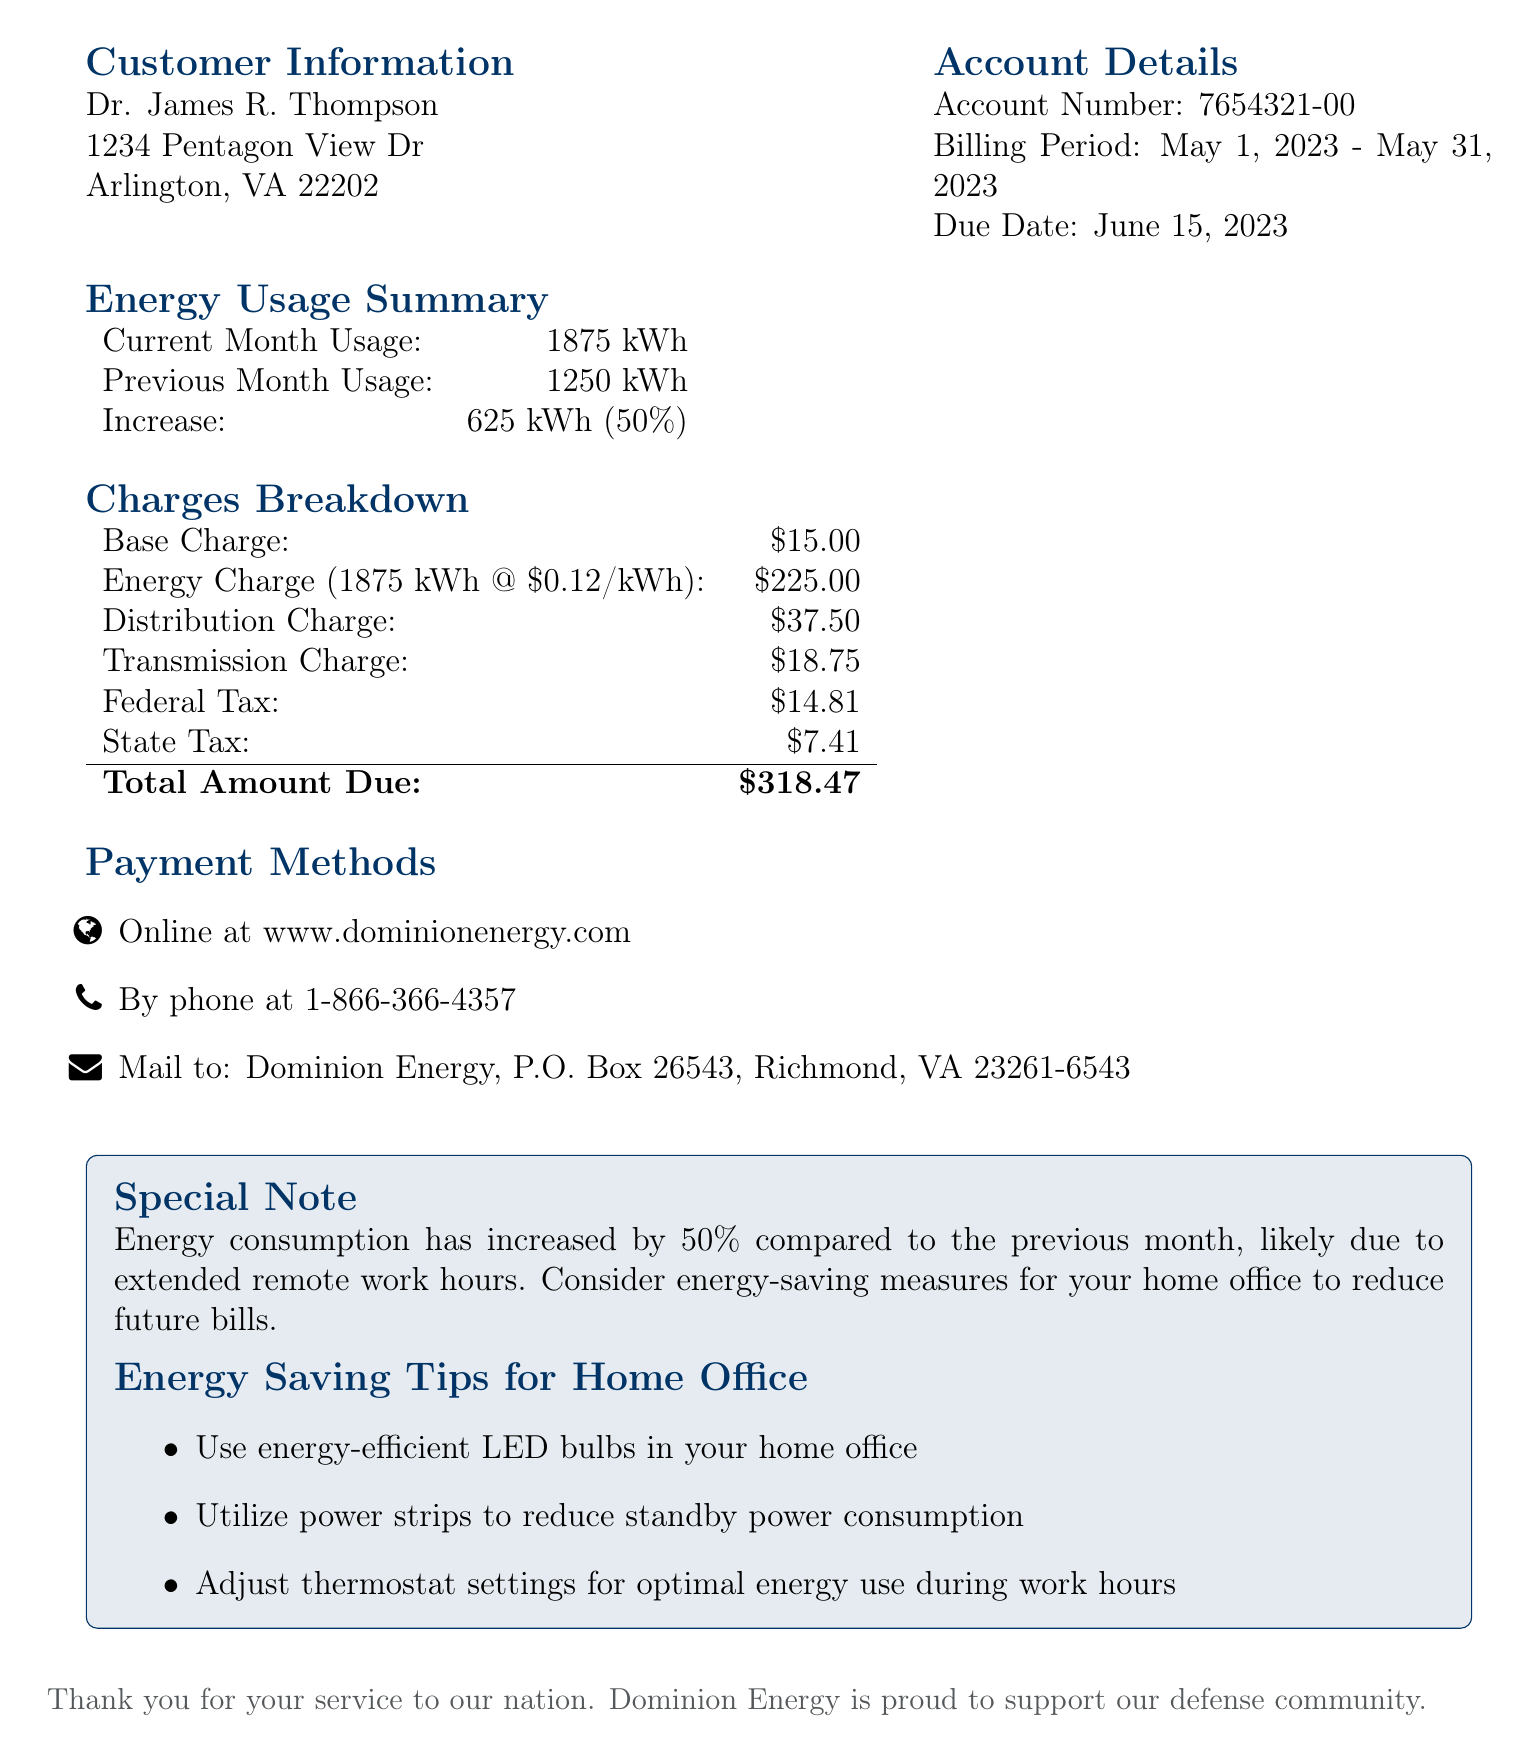What is the billing period? The billing period is stated as May 1, 2023 - May 31, 2023 in the document.
Answer: May 1, 2023 - May 31, 2023 What is the total amount due? The total amount due is calculated at the bottom of the charges breakdown table.
Answer: $318.47 How much energy was consumed in the current month? The current month usage is indicated in the energy usage summary.
Answer: 1875 kWh What was the increase in energy consumption from the previous month? The increase in energy consumption is specified as 625 kWh (50%) in the energy usage summary.
Answer: 625 kWh (50%) What is the base charge? The base charge is listed in the charges breakdown section of the document.
Answer: $15.00 What payment methods are available? The payment methods are detailed in a listed format under payment methods.
Answer: Online, By phone, Mail Why did the energy consumption likely increase? The document states that the increase is likely due to extended remote work hours.
Answer: Extended remote work hours What is one energy-saving tip mentioned in the document? The document provides specific energy-saving tips related to home office use.
Answer: Use energy-efficient LED bulbs 